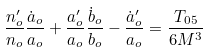<formula> <loc_0><loc_0><loc_500><loc_500>\frac { n ^ { \prime } _ { o } } { n _ { o } } \frac { \dot { a } _ { o } } { a _ { o } } + \frac { a ^ { \prime } _ { o } } { a _ { o } } \frac { \dot { b } _ { o } } { b _ { o } } - \frac { \dot { a } ^ { \prime } _ { o } } { a _ { o } } = \frac { T _ { 0 5 } } { 6 M ^ { 3 } }</formula> 